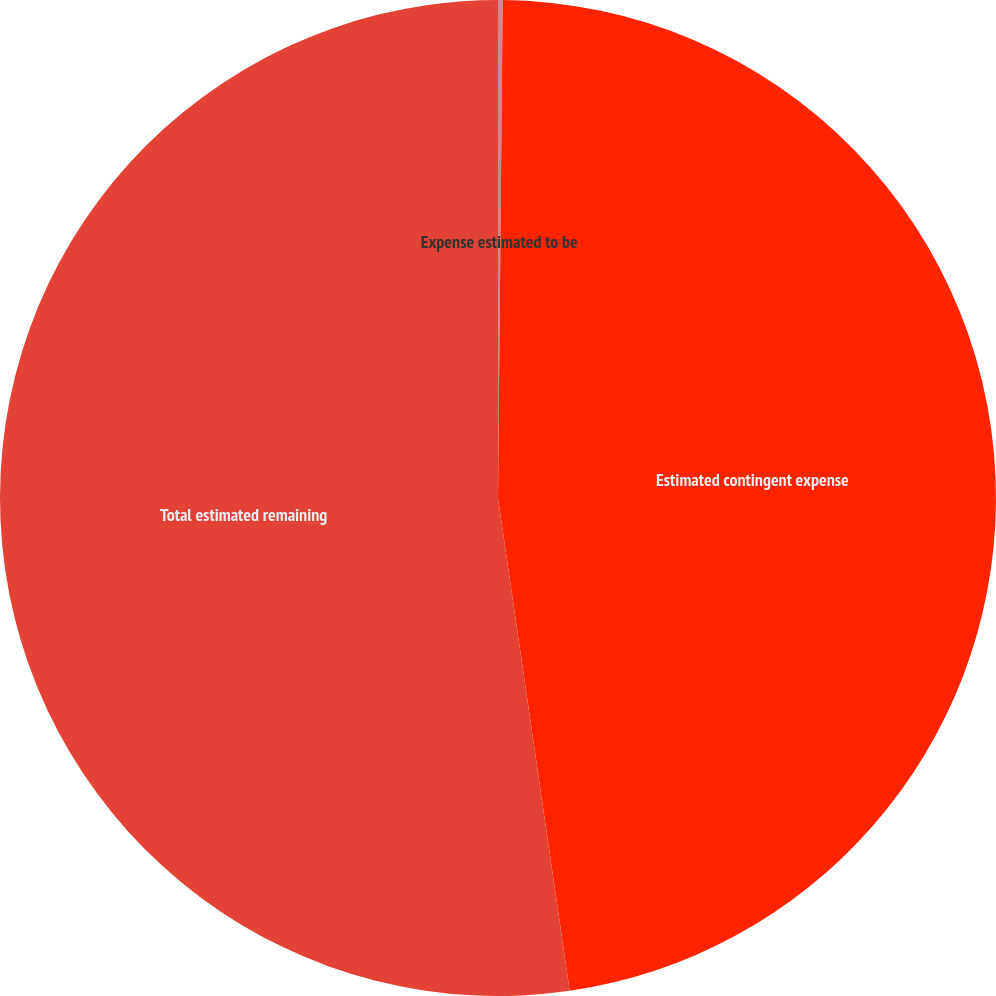Convert chart. <chart><loc_0><loc_0><loc_500><loc_500><pie_chart><fcel>Expense estimated to be<fcel>Estimated contingent expense<fcel>Total estimated remaining<nl><fcel>0.15%<fcel>47.55%<fcel>52.3%<nl></chart> 